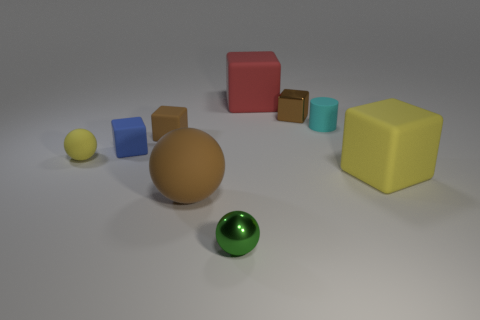What number of other things are the same size as the red thing?
Offer a very short reply. 2. Does the yellow sphere have the same size as the brown cube that is to the left of the green metal ball?
Make the answer very short. Yes. What color is the large rubber cube left of the small matte thing that is behind the tiny brown matte block on the left side of the large yellow cube?
Your response must be concise. Red. What color is the small cylinder?
Offer a terse response. Cyan. Is the number of big yellow things that are to the left of the tiny metallic cube greater than the number of small blue matte cubes that are in front of the small cyan cylinder?
Keep it short and to the point. No. There is a tiny yellow matte thing; does it have the same shape as the brown object that is on the left side of the big sphere?
Make the answer very short. No. There is a brown block that is on the left side of the tiny green metallic ball; is it the same size as the yellow object to the right of the red thing?
Provide a short and direct response. No. Are there any tiny blue cubes that are in front of the large block behind the large thing right of the tiny cylinder?
Keep it short and to the point. Yes. Are there fewer brown metal things that are in front of the large brown object than blocks that are behind the blue matte thing?
Keep it short and to the point. Yes. There is a large brown thing that is the same material as the blue block; what shape is it?
Give a very brief answer. Sphere. 